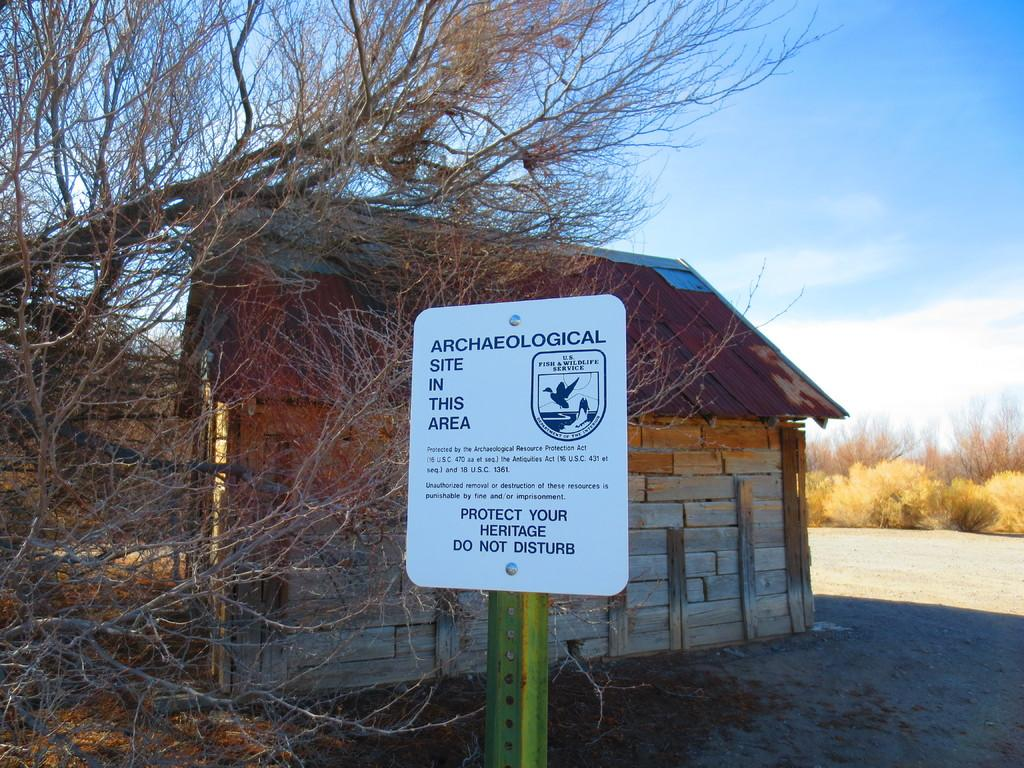What is the main object in the center of the image? There is a board in the center of the image. What can be seen in the background of the image? There is a house and trees in the background of the image. What is visible above the house and trees in the image? The sky is visible in the background of the image. How many grapes are hanging from the board in the image? There are no grapes present in the image; the board is the main object in the center of the image. 